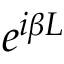Convert formula to latex. <formula><loc_0><loc_0><loc_500><loc_500>e ^ { i \beta L }</formula> 